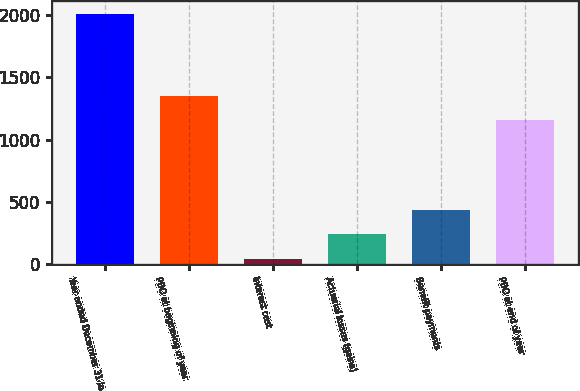Convert chart. <chart><loc_0><loc_0><loc_500><loc_500><bar_chart><fcel>Year ended December 31 in<fcel>PBO at beginning of year<fcel>Interest cost<fcel>Actuarial losses (gains)<fcel>Benefit payments<fcel>PBO at end of year<nl><fcel>2013<fcel>1353.1<fcel>42<fcel>239.1<fcel>436.2<fcel>1156<nl></chart> 